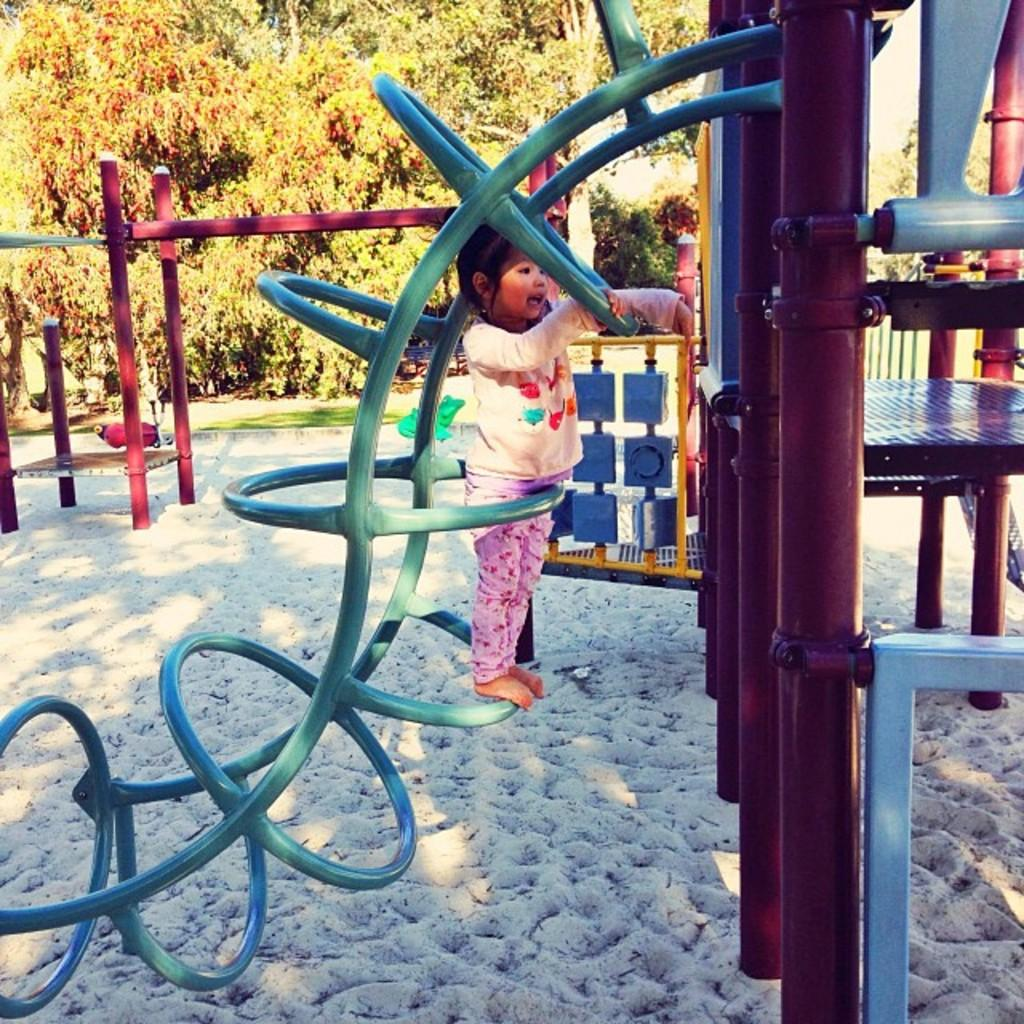What type of area is depicted in the image? There is a kids playing zone in the garden in the image. What activity is the small girl engaged in? The small girl is climbing on pipes in the front of the image. What can be seen in the background of the playing zone? There are trees visible behind the playing zone. What color is the government building in the image? There is no government building present in the image. What season is depicted in the image? The provided facts do not mention any specific season, so it cannot be determined from the image. 